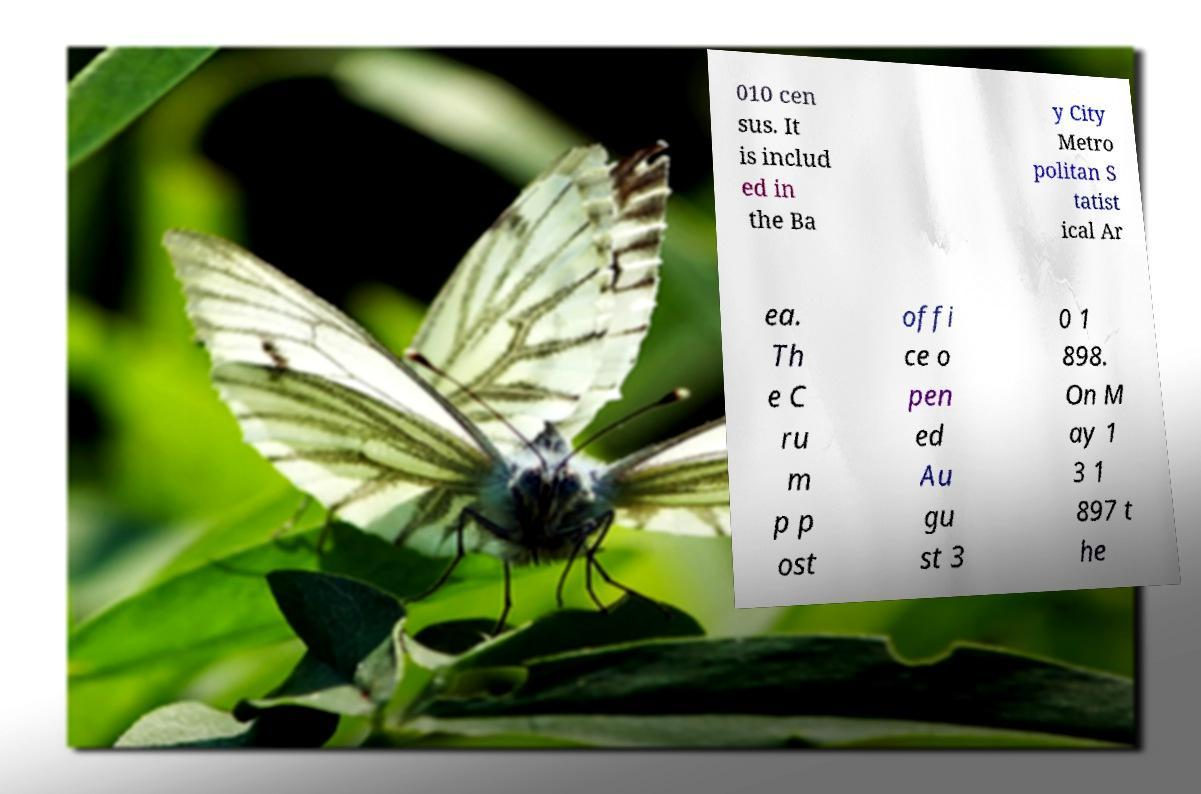Please identify and transcribe the text found in this image. 010 cen sus. It is includ ed in the Ba y City Metro politan S tatist ical Ar ea. Th e C ru m p p ost offi ce o pen ed Au gu st 3 0 1 898. On M ay 1 3 1 897 t he 